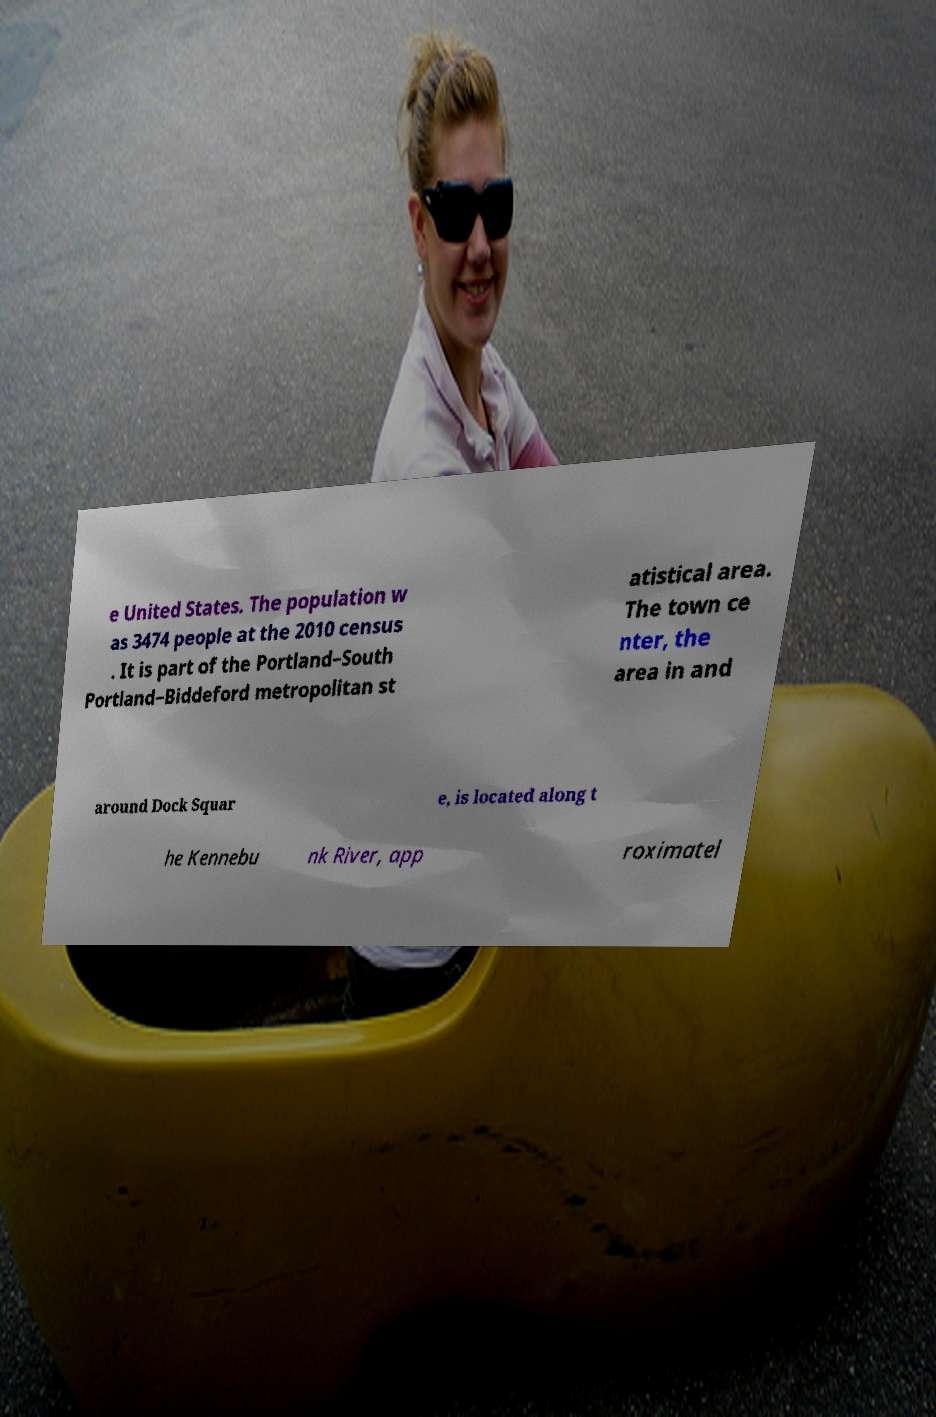Could you extract and type out the text from this image? e United States. The population w as 3474 people at the 2010 census . It is part of the Portland–South Portland–Biddeford metropolitan st atistical area. The town ce nter, the area in and around Dock Squar e, is located along t he Kennebu nk River, app roximatel 